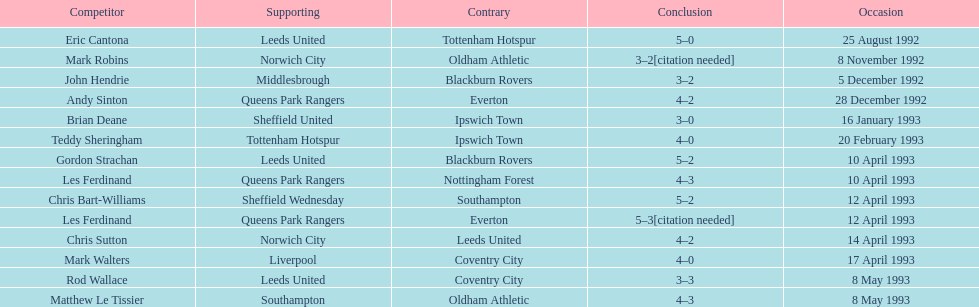Who are the players in 1992-93 fa premier league? Eric Cantona, Mark Robins, John Hendrie, Andy Sinton, Brian Deane, Teddy Sheringham, Gordon Strachan, Les Ferdinand, Chris Bart-Williams, Les Ferdinand, Chris Sutton, Mark Walters, Rod Wallace, Matthew Le Tissier. What is mark robins' result? 3–2[citation needed]. Which player has the same result? John Hendrie. 